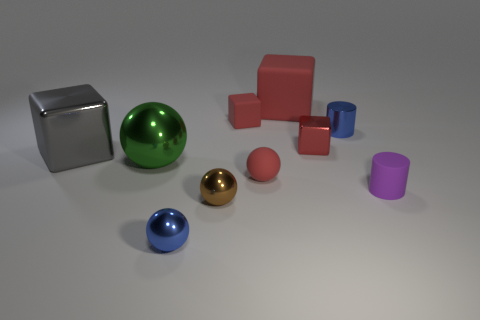Subtract all big metallic cubes. How many cubes are left? 3 Subtract all purple spheres. How many red blocks are left? 3 Subtract 1 balls. How many balls are left? 3 Subtract all purple cylinders. How many cylinders are left? 1 Subtract all cubes. How many objects are left? 6 Subtract 0 green cubes. How many objects are left? 10 Subtract all cyan spheres. Subtract all brown cubes. How many spheres are left? 4 Subtract all large purple objects. Subtract all big green metal balls. How many objects are left? 9 Add 4 small blue metallic cylinders. How many small blue metallic cylinders are left? 5 Add 4 red metal blocks. How many red metal blocks exist? 5 